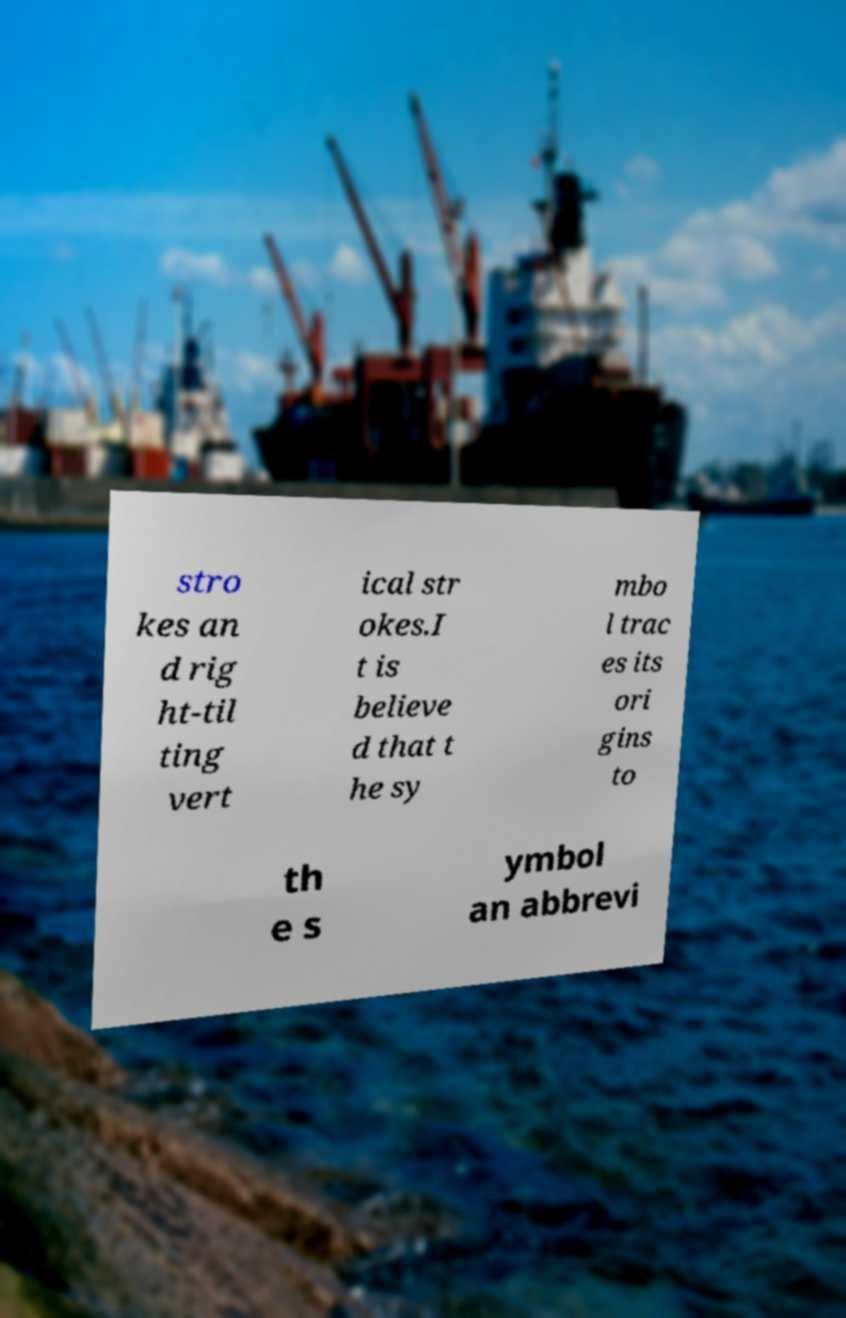For documentation purposes, I need the text within this image transcribed. Could you provide that? stro kes an d rig ht-til ting vert ical str okes.I t is believe d that t he sy mbo l trac es its ori gins to th e s ymbol an abbrevi 